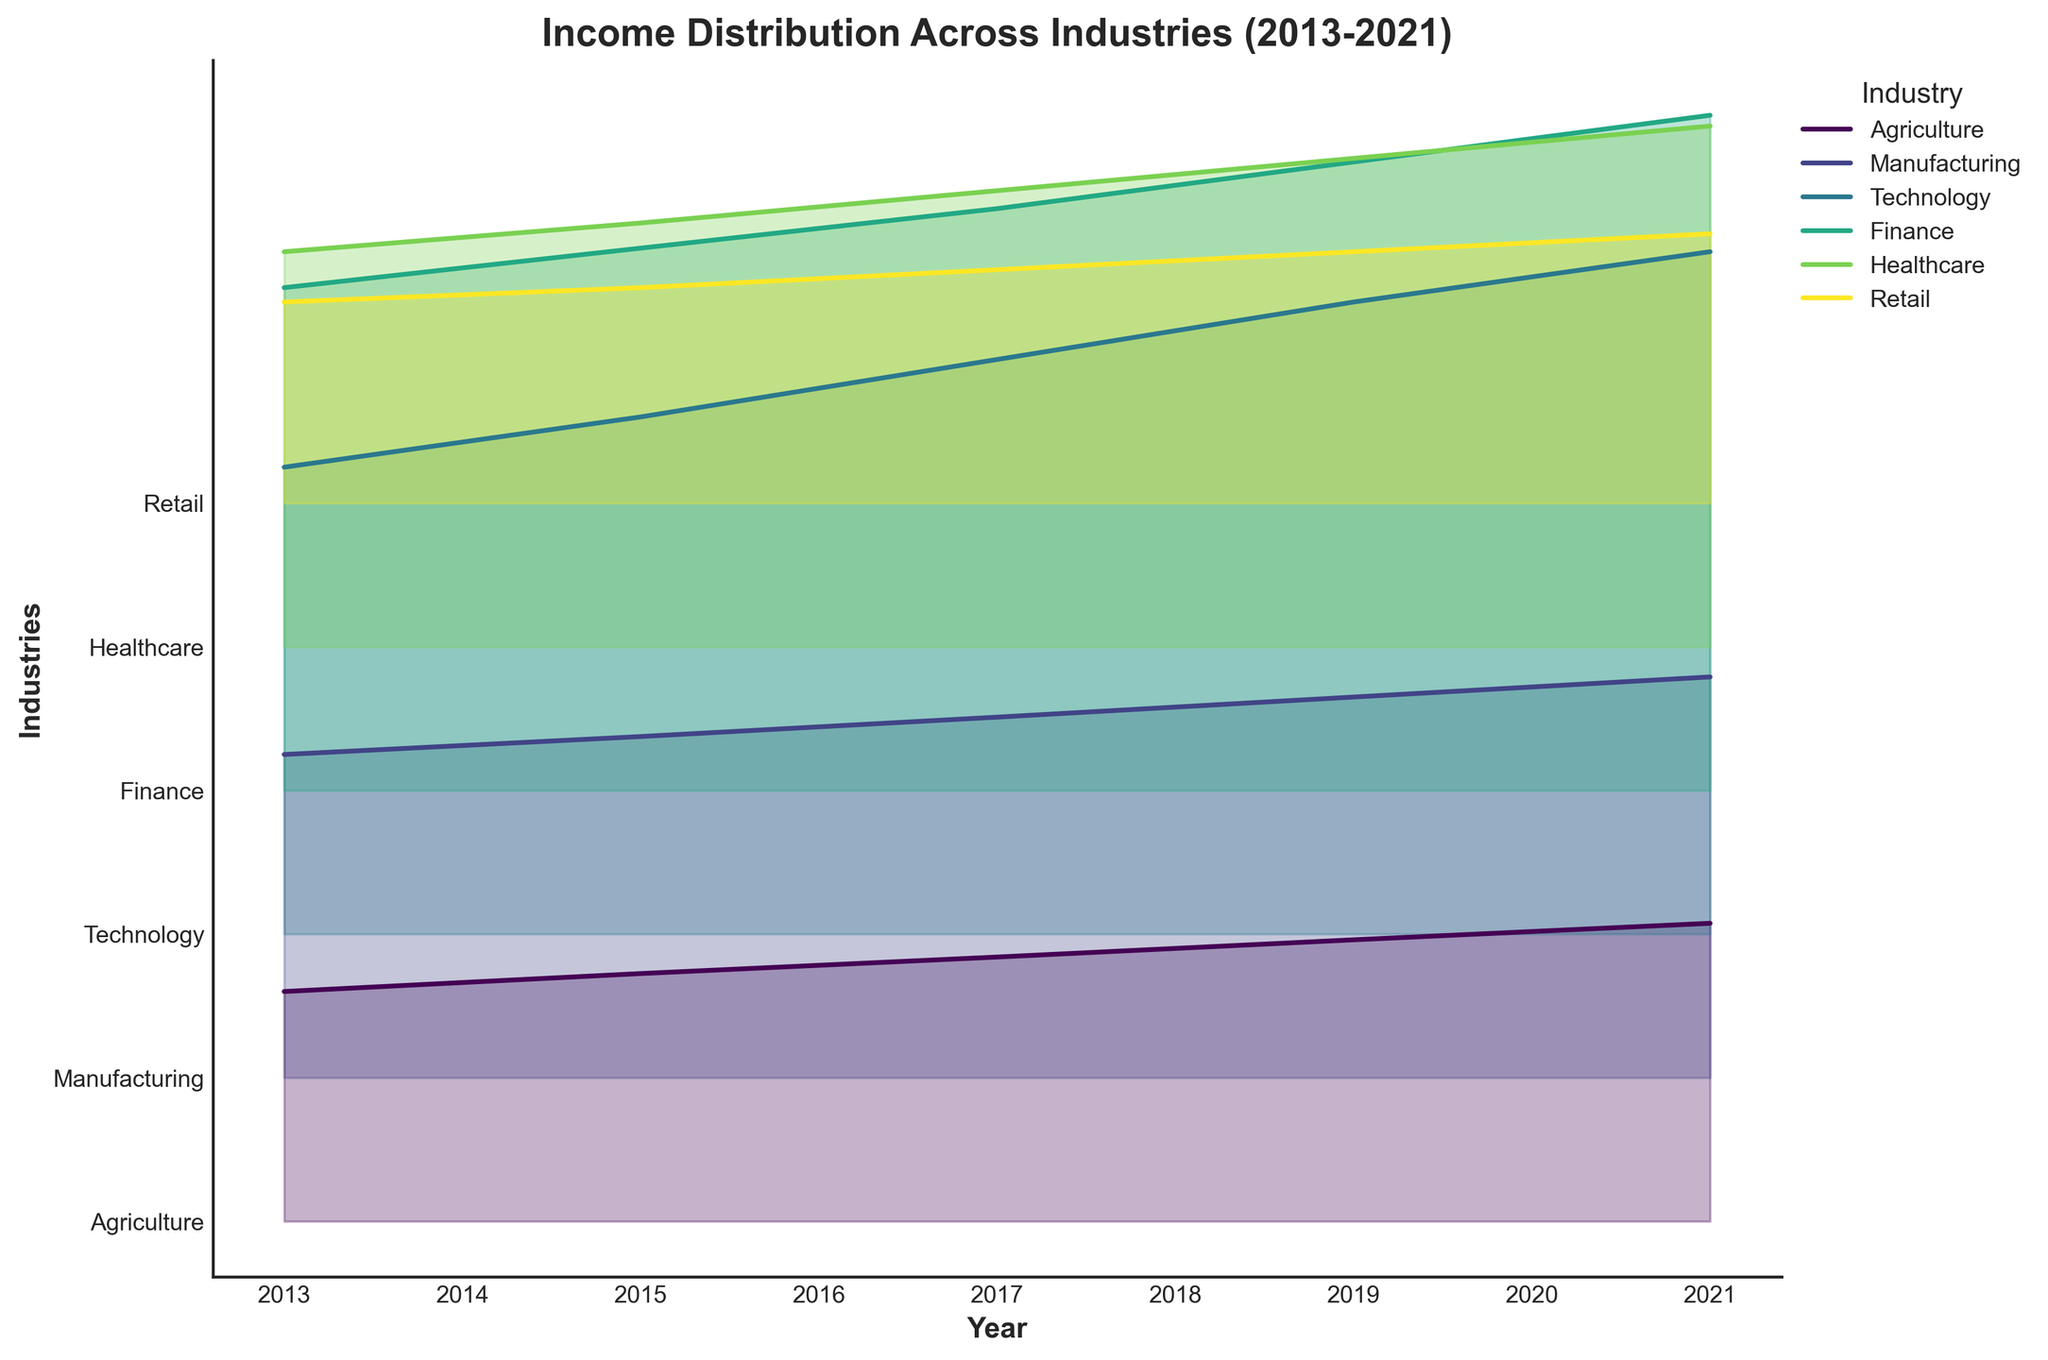What is the title of the plot? The title of the plot is written at the top of the figure, which summarizes the main content depicted.
Answer: Income Distribution Across Industries (2013-2021) What are the x-axis and y-axis labels? The x-axis and y-axis labels are found along the respective axes, providing context for the data.
Answer: The x-axis is "Year" and the y-axis is "Industries" Which industry had the highest income in 2021? By observing the plot, we locate the curve for each industry in 2021 and identify the highest point.
Answer: Technology What is the income difference between the Technology and Retail industries in 2019? Locate the income values for Technology and Retail in 2019 on the plot, then subtract the Retail value from the Technology value.
Answer: 53000 How has the income in the Agriculture industry changed from 2013 to 2021? Look at the Agriculture industry's curve from 2013 to 2021 and note the income change by comparing the values.
Answer: Increased by 9500 Which two industries had the most similar incomes in 2013? Examine the income values across the different industries in 2013 and identify the two industries with the closest values.
Answer: Agriculture and Retail On average, how much did the income in the Manufacturing industry increase per year from 2013 to 2021? Calculate the total income increase from 2013 to 2021 for Manufacturing, then divide by the number of years (2021-2013=8).
Answer: 1350 per year Which industry shows the most consistent growth over the years? Analyze the curves of all industries and identify which one maintains a steady upward trend without sharp fluctuations.
Answer: Technology 